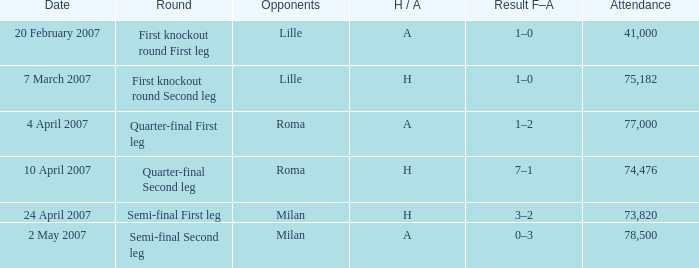Which round involves a lille antagonist and a home / away designation of h? First knockout round Second leg. 